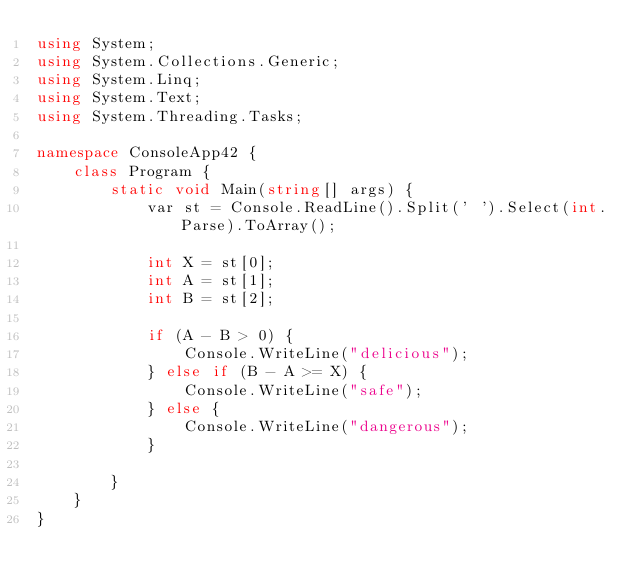<code> <loc_0><loc_0><loc_500><loc_500><_C#_>using System;
using System.Collections.Generic;
using System.Linq;
using System.Text;
using System.Threading.Tasks;

namespace ConsoleApp42 {
    class Program {
        static void Main(string[] args) {
            var st = Console.ReadLine().Split(' ').Select(int.Parse).ToArray();

            int X = st[0];
            int A = st[1];
            int B = st[2];

            if (A - B > 0) {
                Console.WriteLine("delicious");
            } else if (B - A >= X) {
                Console.WriteLine("safe");
            } else {
                Console.WriteLine("dangerous");
            }

        }
    }
}
</code> 